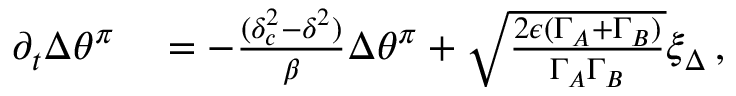Convert formula to latex. <formula><loc_0><loc_0><loc_500><loc_500>\begin{array} { r l } { \partial _ { t } { \Delta \theta ^ { \pi } } } & = - \frac { ( \delta _ { c } ^ { 2 } - \delta ^ { 2 } ) } { \beta } \Delta \theta ^ { \pi } + \sqrt { \frac { 2 \epsilon ( { \Gamma } _ { A } + { \Gamma } _ { B } ) } { \Gamma _ { A } \Gamma _ { B } } } \xi _ { \Delta } \, , } \end{array}</formula> 